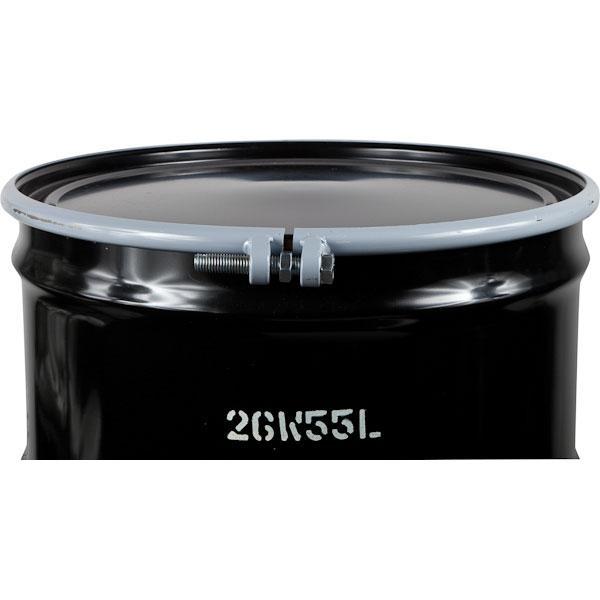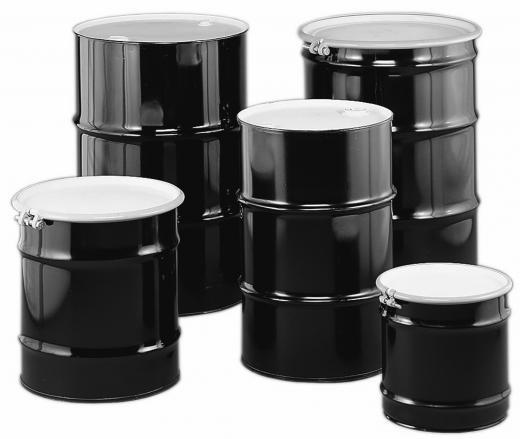The first image is the image on the left, the second image is the image on the right. Analyze the images presented: Is the assertion "All barrels shown are the same color, but one image contains a single barrel, while the other contains at least five." valid? Answer yes or no. Yes. The first image is the image on the left, the second image is the image on the right. Evaluate the accuracy of this statement regarding the images: "There are at least four cans.". Is it true? Answer yes or no. Yes. 